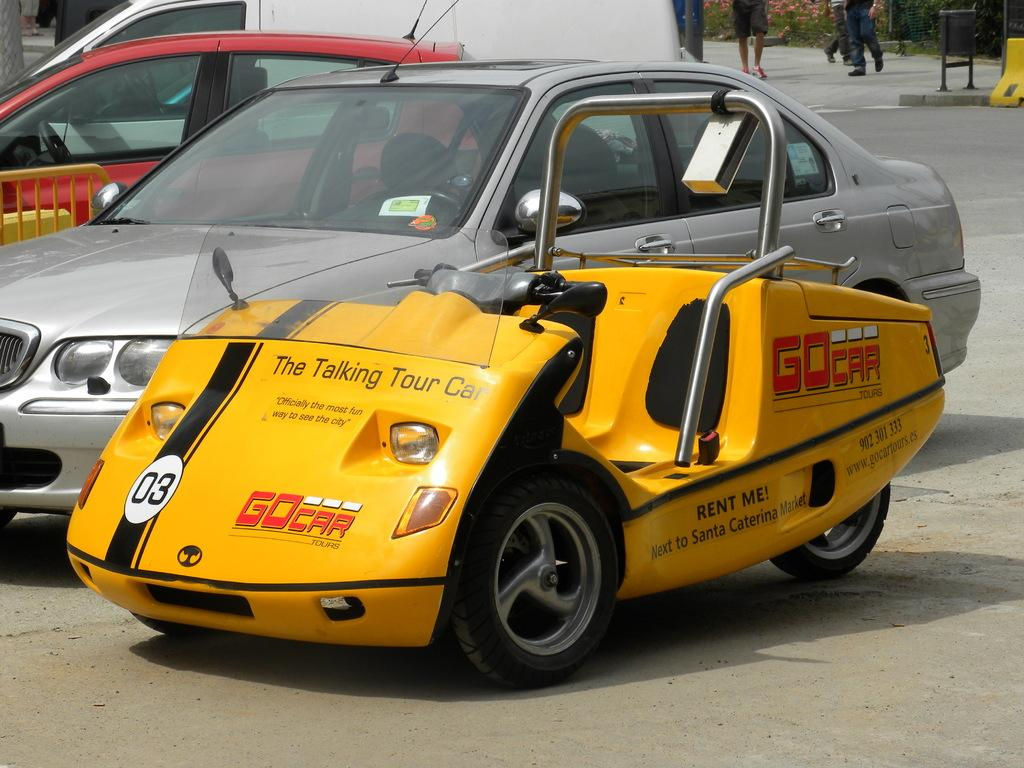<image>
Provide a brief description of the given image. A yellow topless three wheel vehicle in a parking lot. It says GoCar and The Talking Tour Car on the bonnet. 